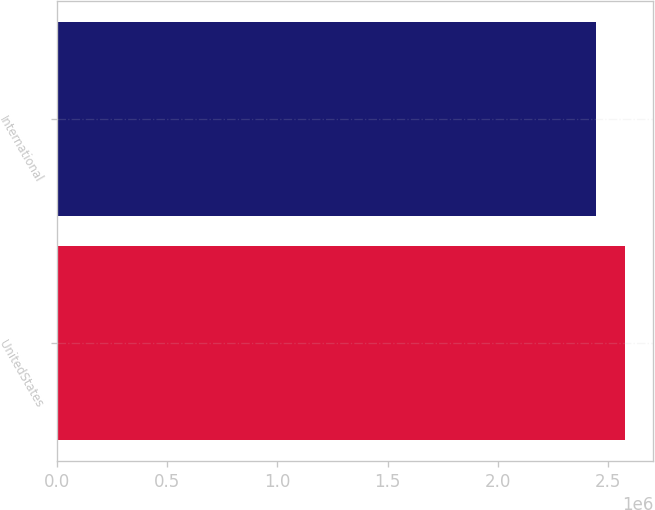Convert chart. <chart><loc_0><loc_0><loc_500><loc_500><bar_chart><fcel>UnitedStates<fcel>International<nl><fcel>2.5757e+06<fcel>2.44413e+06<nl></chart> 